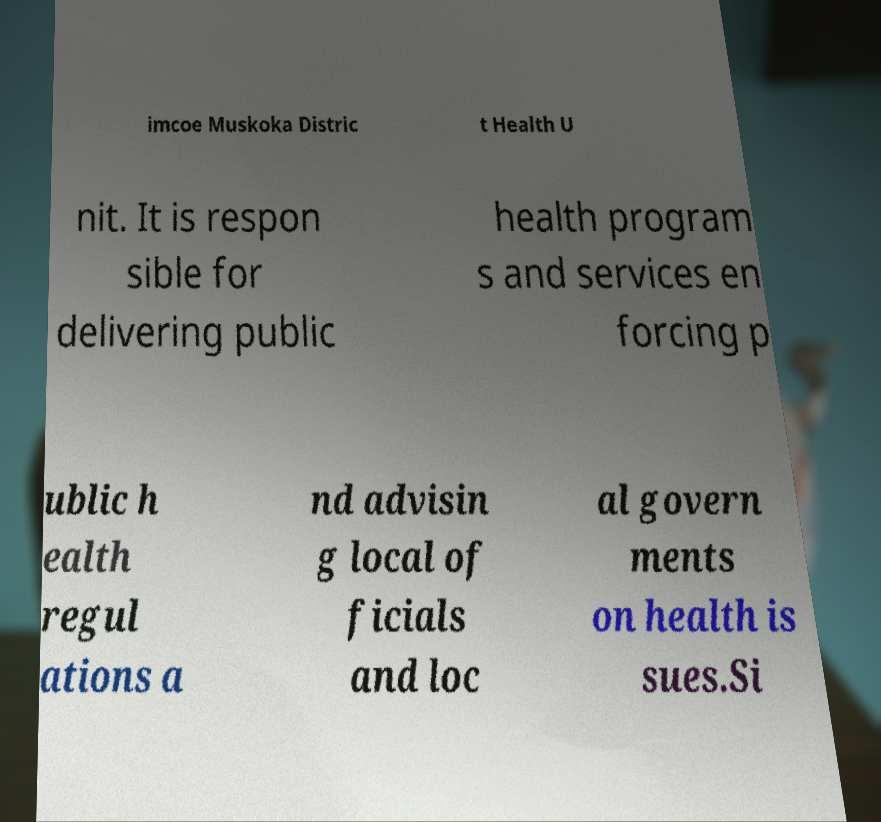I need the written content from this picture converted into text. Can you do that? imcoe Muskoka Distric t Health U nit. It is respon sible for delivering public health program s and services en forcing p ublic h ealth regul ations a nd advisin g local of ficials and loc al govern ments on health is sues.Si 